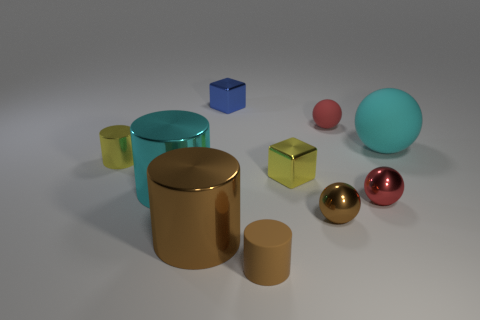There is a cube in front of the cyan object that is behind the small yellow metal cylinder; what color is it?
Provide a succinct answer. Yellow. There is a matte thing that is on the right side of the small rubber thing that is behind the red thing that is in front of the large sphere; what is its size?
Ensure brevity in your answer.  Large. Does the blue cube have the same material as the cube that is in front of the cyan matte sphere?
Keep it short and to the point. Yes. What size is the cyan cylinder that is made of the same material as the brown ball?
Provide a succinct answer. Large. Is there another tiny rubber thing of the same shape as the cyan matte object?
Your answer should be compact. Yes. How many objects are big objects in front of the small red metallic thing or tiny gray matte cylinders?
Provide a succinct answer. 1. The object that is the same color as the large matte sphere is what size?
Make the answer very short. Large. Is the color of the small matte thing behind the small brown rubber object the same as the tiny metallic ball behind the small brown ball?
Your response must be concise. Yes. What size is the blue metallic thing?
Make the answer very short. Small. What number of small things are metal cylinders or yellow shiny cylinders?
Give a very brief answer. 1. 